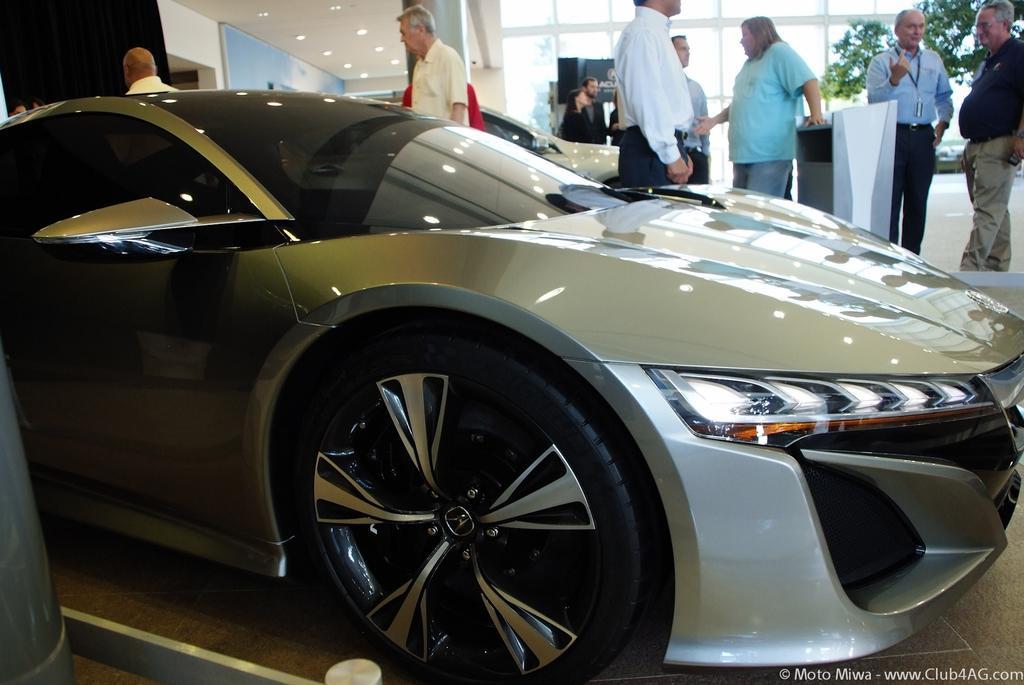Can you describe this image briefly? In this picture I can observe a car parked on the floor. In the background there are some people standing on the floor. On the bottom right side I can observe watermark. 